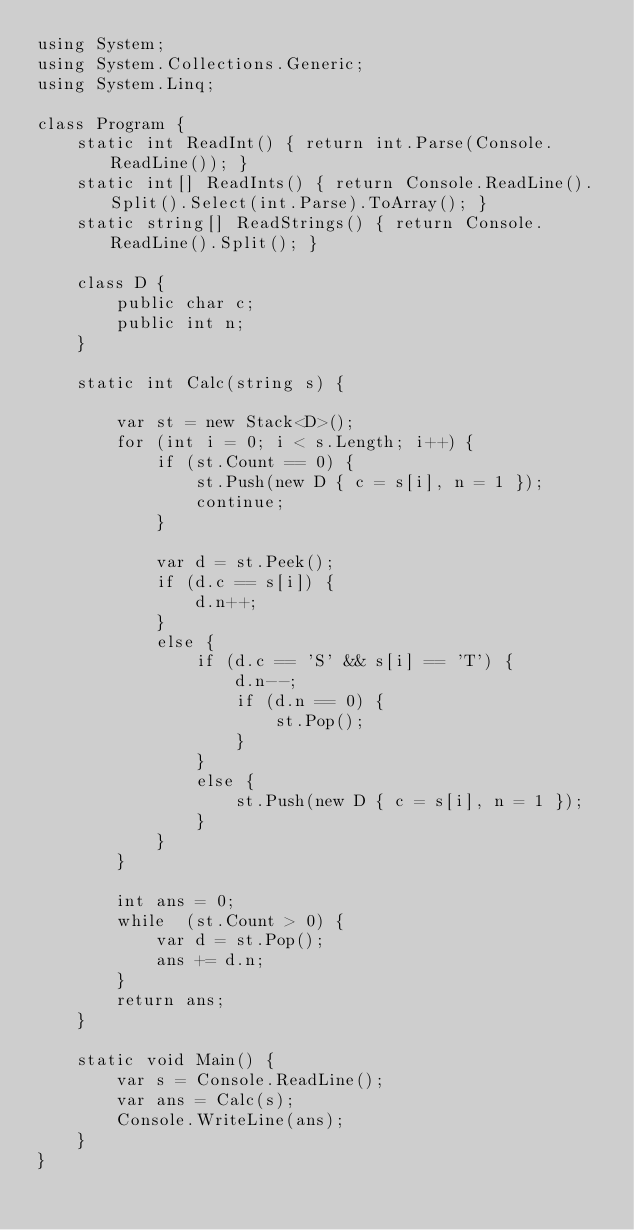Convert code to text. <code><loc_0><loc_0><loc_500><loc_500><_C#_>using System;
using System.Collections.Generic;
using System.Linq;

class Program {
    static int ReadInt() { return int.Parse(Console.ReadLine()); }
    static int[] ReadInts() { return Console.ReadLine().Split().Select(int.Parse).ToArray(); }
    static string[] ReadStrings() { return Console.ReadLine().Split(); }

    class D {
        public char c;
        public int n;
    }

    static int Calc(string s) {

        var st = new Stack<D>();
        for (int i = 0; i < s.Length; i++) {
            if (st.Count == 0) {
                st.Push(new D { c = s[i], n = 1 });
                continue;
            }

            var d = st.Peek();
            if (d.c == s[i]) {
                d.n++;
            }
            else {
                if (d.c == 'S' && s[i] == 'T') {
                    d.n--;
                    if (d.n == 0) {
                        st.Pop();
                    }
                }
                else {
                    st.Push(new D { c = s[i], n = 1 });
                }
            }
        }

        int ans = 0;
        while  (st.Count > 0) {
            var d = st.Pop();
            ans += d.n;
        }
        return ans;
    }

    static void Main() {
        var s = Console.ReadLine();
        var ans = Calc(s);
        Console.WriteLine(ans);
    }
}</code> 